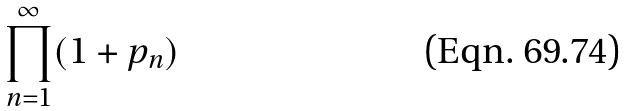<formula> <loc_0><loc_0><loc_500><loc_500>\prod _ { n = 1 } ^ { \infty } ( 1 + p _ { n } )</formula> 